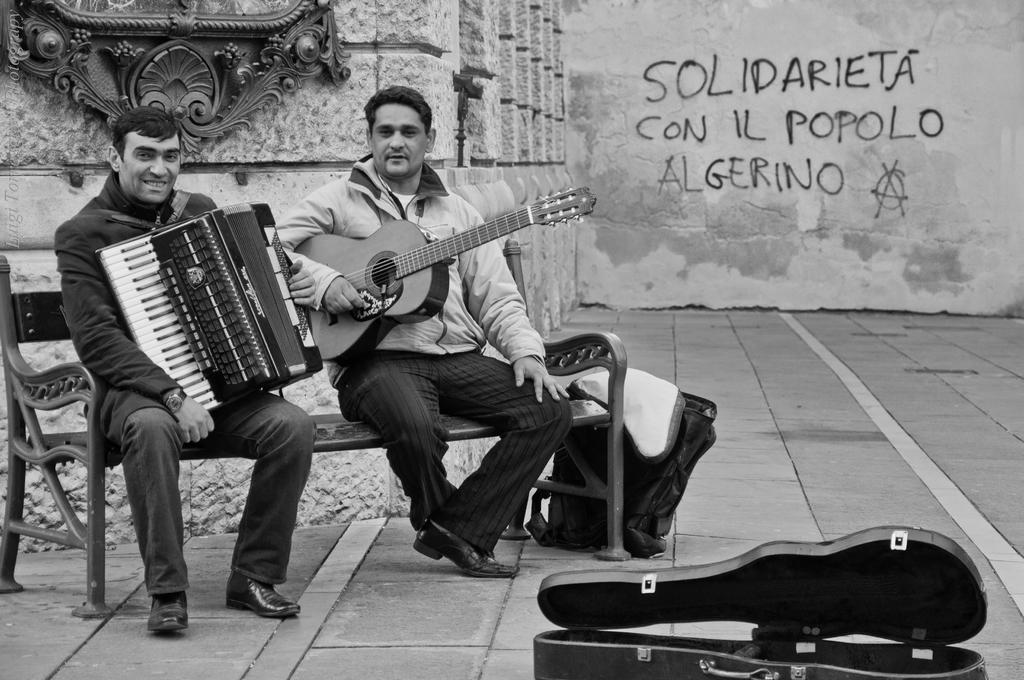Can you describe this image briefly? Here we can see two men sitting on a bench, the person on right side is holding a guitar and the person on the left side is holding another musical instrument and in front of them we can see the box of guitar and beside them we can see a bag and behind them we can see a wall written something on it 